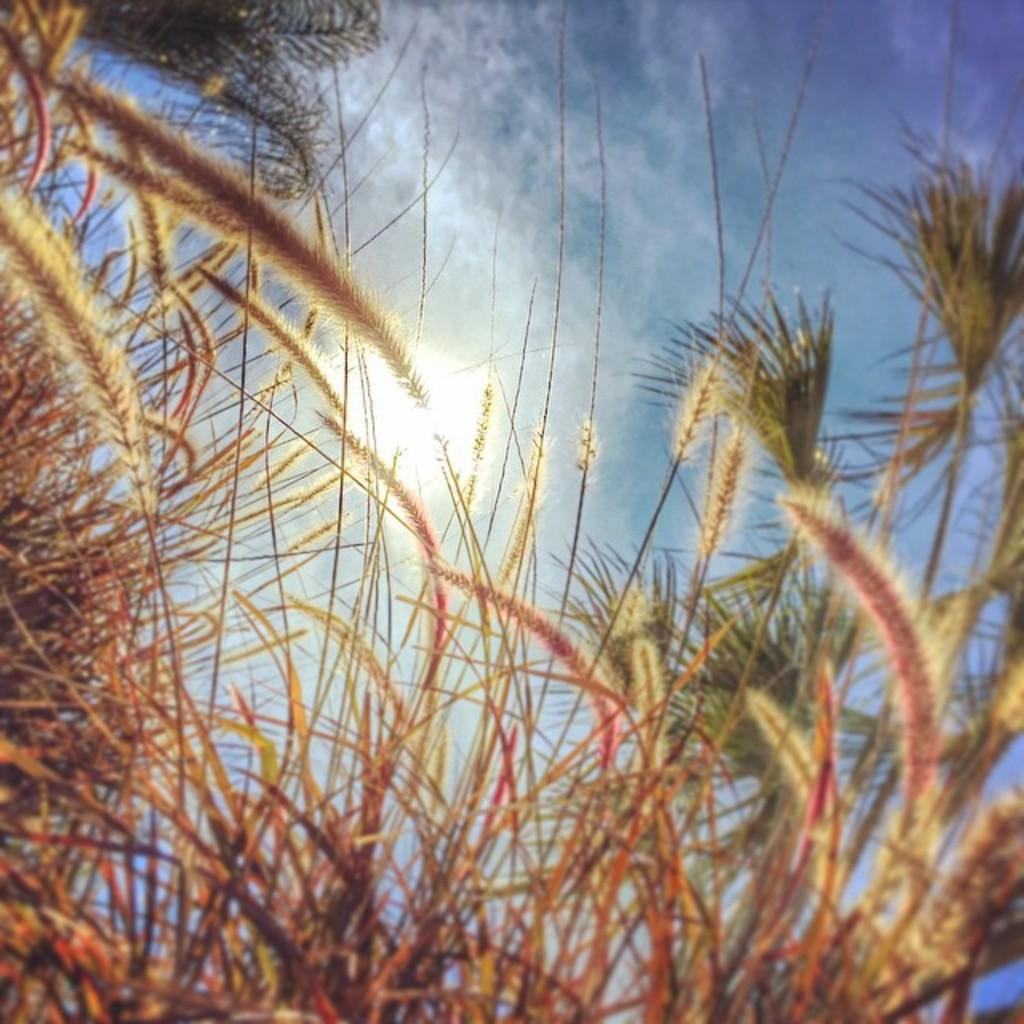Please provide a concise description of this image. In this picture I can see few plants at the bottom, there is the sky at the top. 